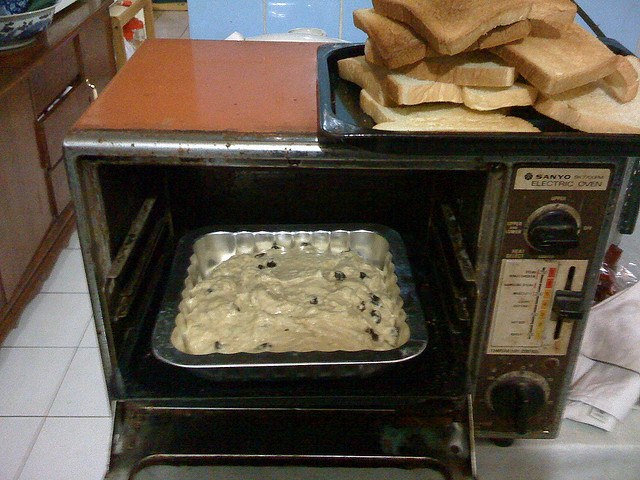Please transcribe the text information in this image. SANYO 